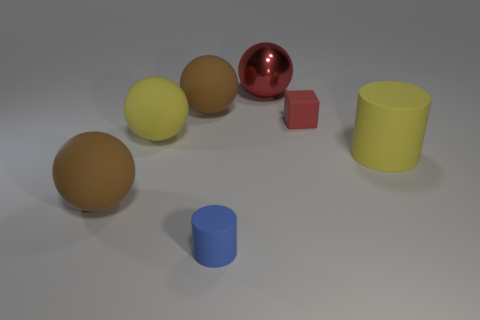Subtract all red balls. How many balls are left? 3 Subtract all matte spheres. How many spheres are left? 1 Add 2 big cylinders. How many objects exist? 9 Subtract all gray spheres. Subtract all blue blocks. How many spheres are left? 4 Subtract all spheres. How many objects are left? 3 Add 6 large yellow spheres. How many large yellow spheres exist? 7 Subtract 0 gray cylinders. How many objects are left? 7 Subtract all cylinders. Subtract all small things. How many objects are left? 3 Add 6 brown matte spheres. How many brown matte spheres are left? 8 